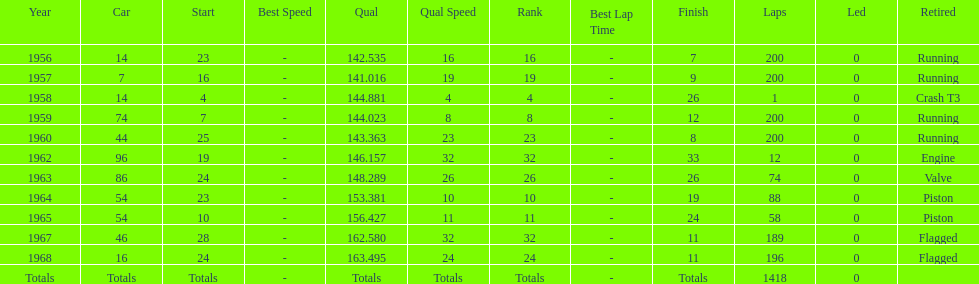Did bob veith drive more indy 500 laps in the 1950s or 1960s? 1960s. 